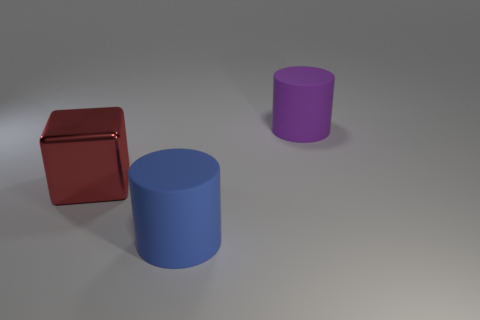Imagine these objects are characters in a story. What personalities might they have? The red cube might be the stoic and dependable character, always steady and strong. The blue cylinder could be the flexible thinker, able to adapt and roll with the changes, while the purple cylinder might be a slightly smaller version of the blue, perhaps a sidekick or a younger sibling character, echoing the traits of its larger companion. Could you continue the story? What kind of adventure could they go on? Certainly! Our three characters might go on an adventure through a world where geometry defines destiny. The red cube, valuing stability and balance, might lead the group to a mysterious pyramid, seeking the wisdom within. The blue cylinder, with its innovative spirit, would suggest creative ways to overcome obstacles, like rolling across chasms. The purple cylinder, eager and curious, may discover secret passages with its smaller size, leading them to a forgotten city made of shapes where every object equates to a different personality. 